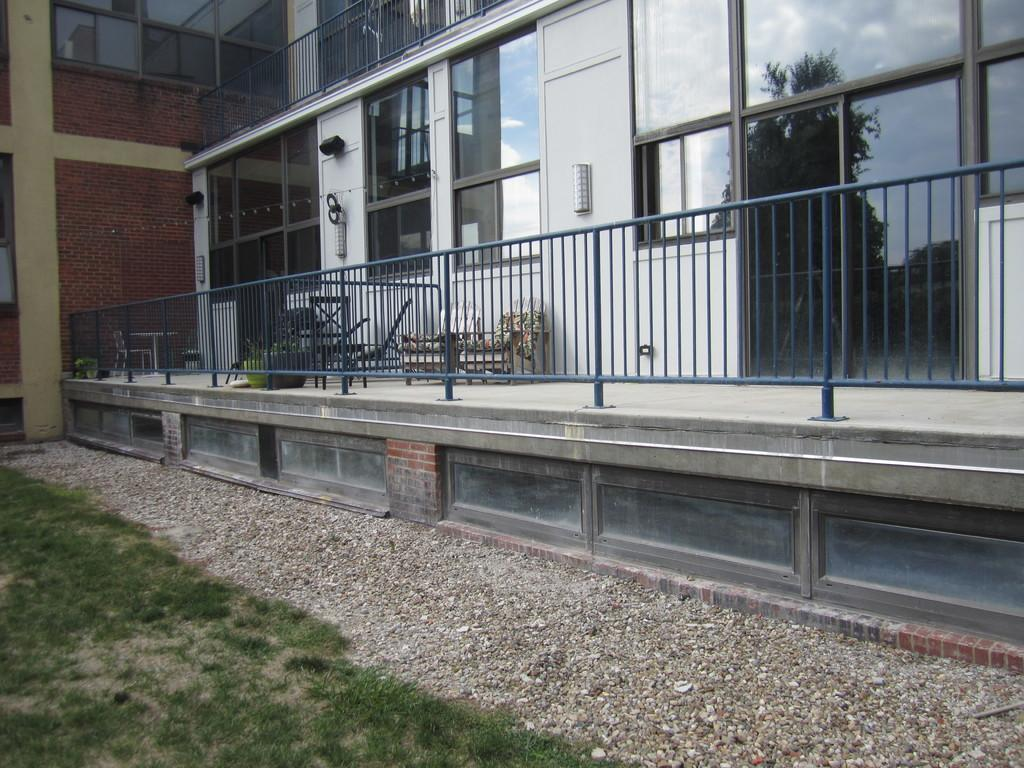What is present in the foreground of the image? There are small pebbles and grassland in the foreground of the image. What can be seen in the background of the image? There is a building and chairs in the background of the image. What type of minute is visible on the roof of the building in the image? There is no mention of a minute or any specific detail about the building's roof in the provided facts, so it cannot be determined from the image. What government policies are being discussed in the image? There is no indication of any government policies or discussions in the image. 